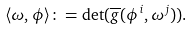<formula> <loc_0><loc_0><loc_500><loc_500>\langle \omega , \phi \rangle \colon = \det ( \overline { g } ( \phi ^ { i } , \omega ^ { j } ) ) .</formula> 